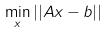<formula> <loc_0><loc_0><loc_500><loc_500>\min _ { x } | | A x - b | |</formula> 